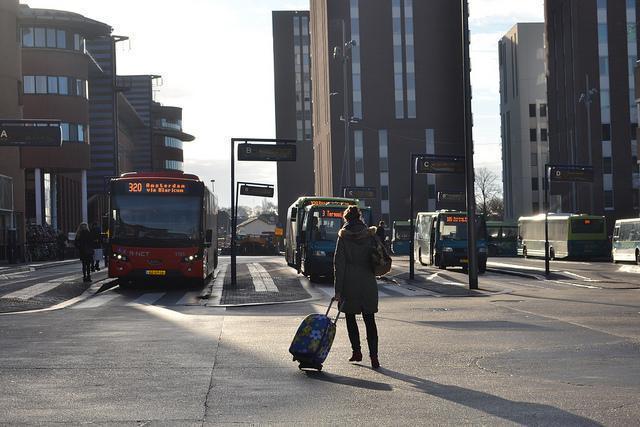What activity is the woman participating in?
Indicate the correct choice and explain in the format: 'Answer: answer
Rationale: rationale.'
Options: Shopping, cleaning, sleep, travel. Answer: travel.
Rationale: The woman is participating in world travel. 